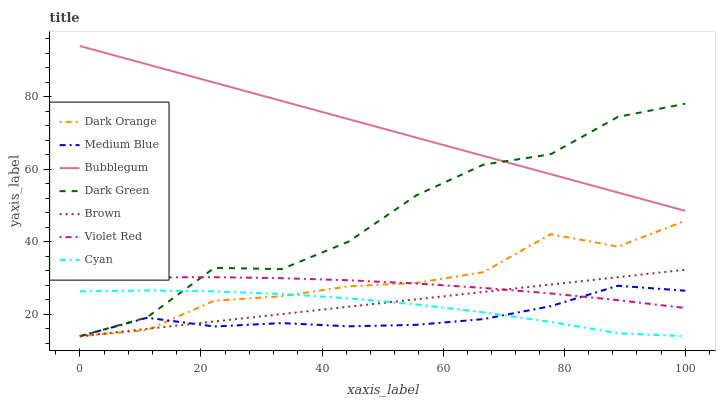Does Medium Blue have the minimum area under the curve?
Answer yes or no. Yes. Does Bubblegum have the maximum area under the curve?
Answer yes or no. Yes. Does Violet Red have the minimum area under the curve?
Answer yes or no. No. Does Violet Red have the maximum area under the curve?
Answer yes or no. No. Is Brown the smoothest?
Answer yes or no. Yes. Is Dark Green the roughest?
Answer yes or no. Yes. Is Violet Red the smoothest?
Answer yes or no. No. Is Violet Red the roughest?
Answer yes or no. No. Does Dark Orange have the lowest value?
Answer yes or no. Yes. Does Violet Red have the lowest value?
Answer yes or no. No. Does Bubblegum have the highest value?
Answer yes or no. Yes. Does Violet Red have the highest value?
Answer yes or no. No. Is Cyan less than Violet Red?
Answer yes or no. Yes. Is Bubblegum greater than Dark Orange?
Answer yes or no. Yes. Does Bubblegum intersect Dark Green?
Answer yes or no. Yes. Is Bubblegum less than Dark Green?
Answer yes or no. No. Is Bubblegum greater than Dark Green?
Answer yes or no. No. Does Cyan intersect Violet Red?
Answer yes or no. No. 